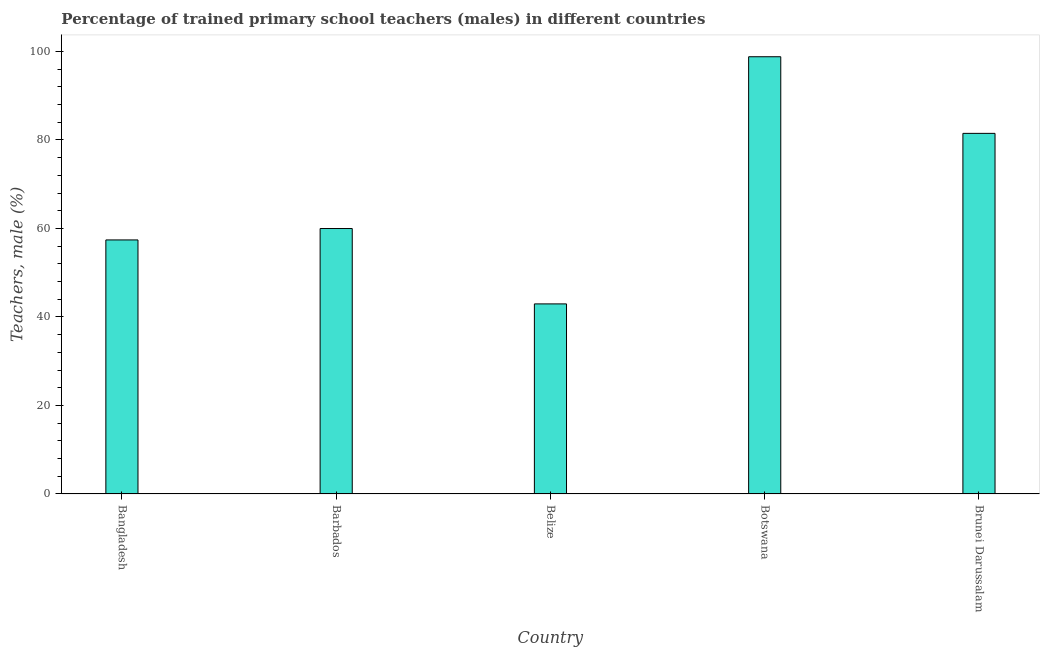Does the graph contain grids?
Provide a succinct answer. No. What is the title of the graph?
Provide a succinct answer. Percentage of trained primary school teachers (males) in different countries. What is the label or title of the Y-axis?
Offer a very short reply. Teachers, male (%). What is the percentage of trained male teachers in Barbados?
Provide a succinct answer. 59.99. Across all countries, what is the maximum percentage of trained male teachers?
Your answer should be compact. 98.8. Across all countries, what is the minimum percentage of trained male teachers?
Your answer should be compact. 42.95. In which country was the percentage of trained male teachers maximum?
Ensure brevity in your answer.  Botswana. In which country was the percentage of trained male teachers minimum?
Provide a short and direct response. Belize. What is the sum of the percentage of trained male teachers?
Your answer should be compact. 340.63. What is the difference between the percentage of trained male teachers in Bangladesh and Belize?
Your response must be concise. 14.46. What is the average percentage of trained male teachers per country?
Offer a very short reply. 68.13. What is the median percentage of trained male teachers?
Provide a short and direct response. 59.99. What is the ratio of the percentage of trained male teachers in Bangladesh to that in Belize?
Give a very brief answer. 1.34. What is the difference between the highest and the second highest percentage of trained male teachers?
Your answer should be very brief. 17.32. Is the sum of the percentage of trained male teachers in Bangladesh and Botswana greater than the maximum percentage of trained male teachers across all countries?
Your answer should be compact. Yes. What is the difference between the highest and the lowest percentage of trained male teachers?
Offer a very short reply. 55.85. In how many countries, is the percentage of trained male teachers greater than the average percentage of trained male teachers taken over all countries?
Provide a succinct answer. 2. Are all the bars in the graph horizontal?
Your response must be concise. No. What is the difference between two consecutive major ticks on the Y-axis?
Your answer should be compact. 20. What is the Teachers, male (%) in Bangladesh?
Offer a terse response. 57.41. What is the Teachers, male (%) in Barbados?
Keep it short and to the point. 59.99. What is the Teachers, male (%) in Belize?
Ensure brevity in your answer.  42.95. What is the Teachers, male (%) in Botswana?
Your answer should be compact. 98.8. What is the Teachers, male (%) in Brunei Darussalam?
Give a very brief answer. 81.49. What is the difference between the Teachers, male (%) in Bangladesh and Barbados?
Provide a short and direct response. -2.58. What is the difference between the Teachers, male (%) in Bangladesh and Belize?
Offer a terse response. 14.46. What is the difference between the Teachers, male (%) in Bangladesh and Botswana?
Give a very brief answer. -41.4. What is the difference between the Teachers, male (%) in Bangladesh and Brunei Darussalam?
Keep it short and to the point. -24.08. What is the difference between the Teachers, male (%) in Barbados and Belize?
Offer a very short reply. 17.03. What is the difference between the Teachers, male (%) in Barbados and Botswana?
Keep it short and to the point. -38.82. What is the difference between the Teachers, male (%) in Barbados and Brunei Darussalam?
Your response must be concise. -21.5. What is the difference between the Teachers, male (%) in Belize and Botswana?
Provide a short and direct response. -55.85. What is the difference between the Teachers, male (%) in Belize and Brunei Darussalam?
Offer a terse response. -38.53. What is the difference between the Teachers, male (%) in Botswana and Brunei Darussalam?
Your answer should be very brief. 17.32. What is the ratio of the Teachers, male (%) in Bangladesh to that in Belize?
Give a very brief answer. 1.34. What is the ratio of the Teachers, male (%) in Bangladesh to that in Botswana?
Offer a terse response. 0.58. What is the ratio of the Teachers, male (%) in Bangladesh to that in Brunei Darussalam?
Your answer should be very brief. 0.7. What is the ratio of the Teachers, male (%) in Barbados to that in Belize?
Your answer should be very brief. 1.4. What is the ratio of the Teachers, male (%) in Barbados to that in Botswana?
Make the answer very short. 0.61. What is the ratio of the Teachers, male (%) in Barbados to that in Brunei Darussalam?
Keep it short and to the point. 0.74. What is the ratio of the Teachers, male (%) in Belize to that in Botswana?
Your answer should be very brief. 0.43. What is the ratio of the Teachers, male (%) in Belize to that in Brunei Darussalam?
Your answer should be compact. 0.53. What is the ratio of the Teachers, male (%) in Botswana to that in Brunei Darussalam?
Provide a short and direct response. 1.21. 